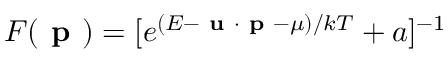<formula> <loc_0><loc_0><loc_500><loc_500>F ( p ) = [ e ^ { ( E - u \cdot p - \mu ) / k T } + a ] ^ { - 1 }</formula> 